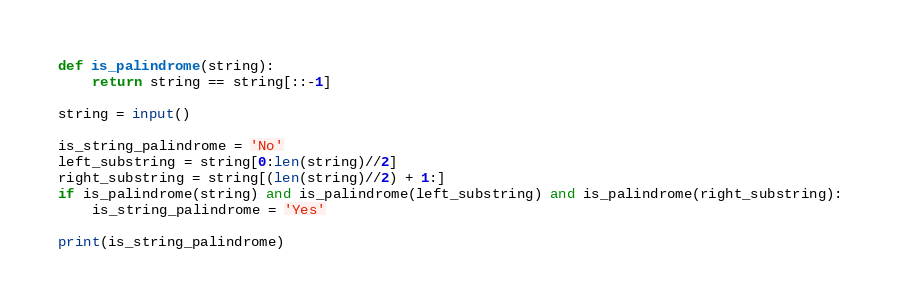<code> <loc_0><loc_0><loc_500><loc_500><_Python_>def is_palindrome(string):
    return string == string[::-1]

string = input()

is_string_palindrome = 'No'
left_substring = string[0:len(string)//2]
right_substring = string[(len(string)//2) + 1:]
if is_palindrome(string) and is_palindrome(left_substring) and is_palindrome(right_substring):
    is_string_palindrome = 'Yes'

print(is_string_palindrome)</code> 